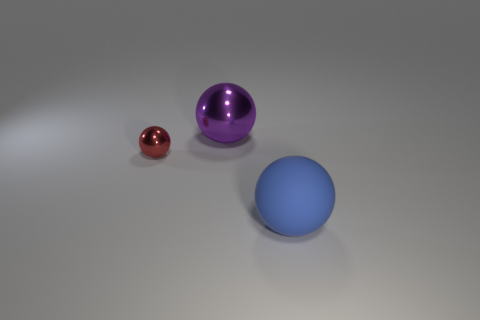Is the number of large balls on the right side of the small object greater than the number of green rubber cylinders?
Make the answer very short. Yes. How many blocks are big purple objects or big blue rubber things?
Your response must be concise. 0. The thing that is both to the left of the rubber ball and in front of the large purple shiny object has what shape?
Your answer should be compact. Sphere. Are there the same number of balls that are in front of the large purple ball and things on the left side of the large blue matte object?
Keep it short and to the point. Yes. How many objects are either large blue objects or tiny red balls?
Keep it short and to the point. 2. There is a ball that is the same size as the blue matte thing; what is its color?
Your response must be concise. Purple. How many things are either large rubber objects that are right of the tiny red thing or big objects in front of the small red ball?
Your answer should be very brief. 1. Are there the same number of tiny red objects left of the large purple thing and tiny metal things?
Your response must be concise. Yes. Do the shiny object behind the small red thing and the metal ball on the left side of the large metal thing have the same size?
Provide a succinct answer. No. How many other objects are the same size as the blue matte object?
Ensure brevity in your answer.  1. 